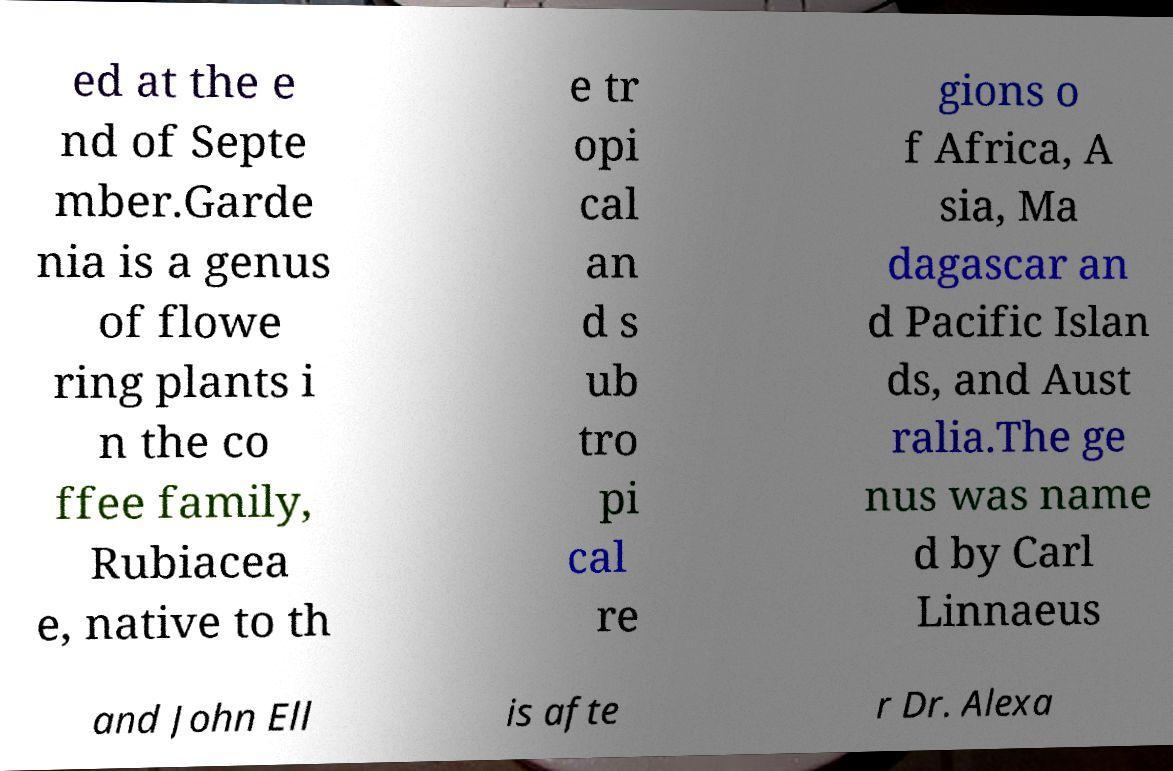Please identify and transcribe the text found in this image. ed at the e nd of Septe mber.Garde nia is a genus of flowe ring plants i n the co ffee family, Rubiacea e, native to th e tr opi cal an d s ub tro pi cal re gions o f Africa, A sia, Ma dagascar an d Pacific Islan ds, and Aust ralia.The ge nus was name d by Carl Linnaeus and John Ell is afte r Dr. Alexa 